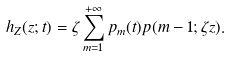<formula> <loc_0><loc_0><loc_500><loc_500>h _ { Z } ( z ; t ) = \zeta \sum _ { m = 1 } ^ { + \infty } p _ { m } ( t ) p ( m - 1 ; \zeta z ) .</formula> 